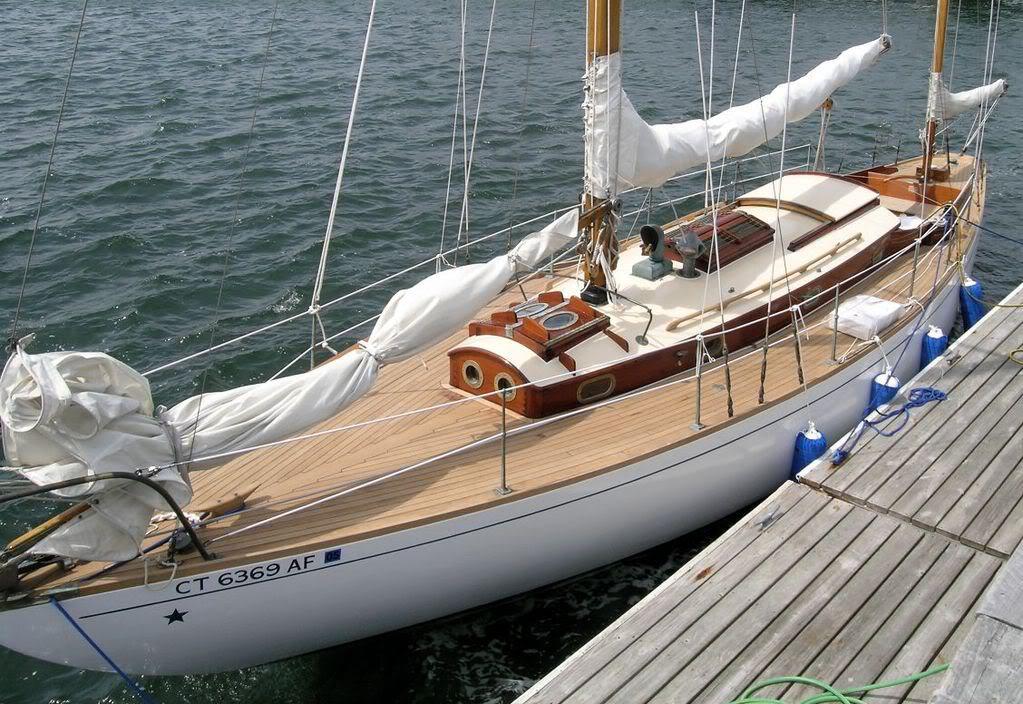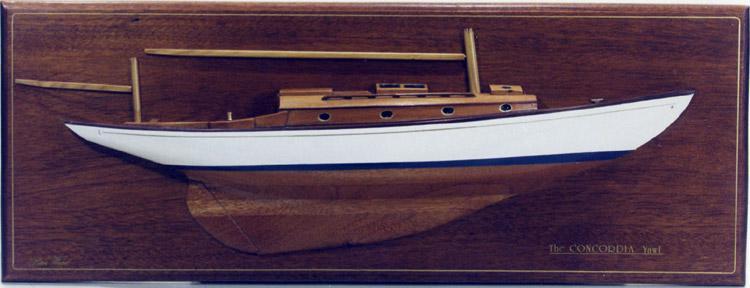The first image is the image on the left, the second image is the image on the right. Given the left and right images, does the statement "The right image shows a model ship on a wooden plaque." hold true? Answer yes or no. Yes. The first image is the image on the left, the second image is the image on the right. For the images displayed, is the sentence "An image shows at least one undocked boat surrounded by water." factually correct? Answer yes or no. No. 